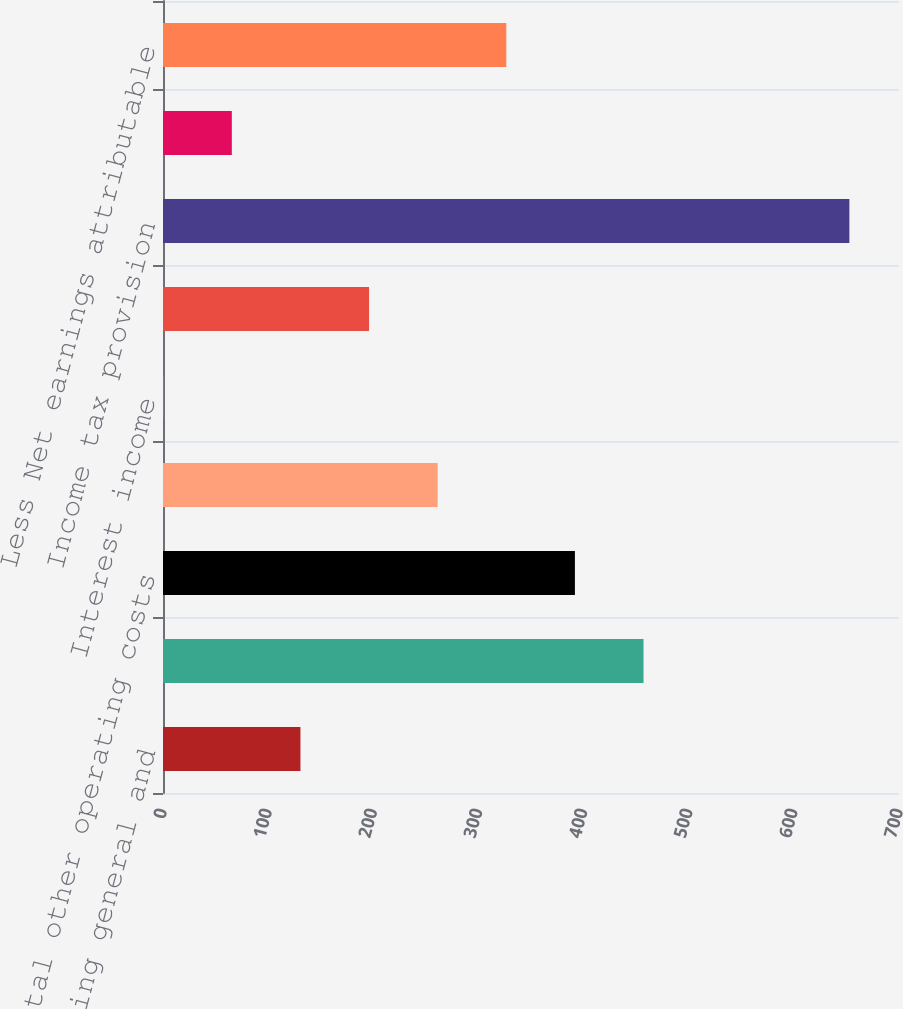Convert chart. <chart><loc_0><loc_0><loc_500><loc_500><bar_chart><fcel>Selling general and<fcel>Other operating-net<fcel>Total other operating costs<fcel>Interest expense<fcel>Interest income<fcel>Other non-operating-net<fcel>Income tax provision<fcel>Equity in earnings of<fcel>Less Net earnings attributable<nl><fcel>130.72<fcel>457.02<fcel>391.76<fcel>261.24<fcel>0.2<fcel>195.98<fcel>652.8<fcel>65.46<fcel>326.5<nl></chart> 